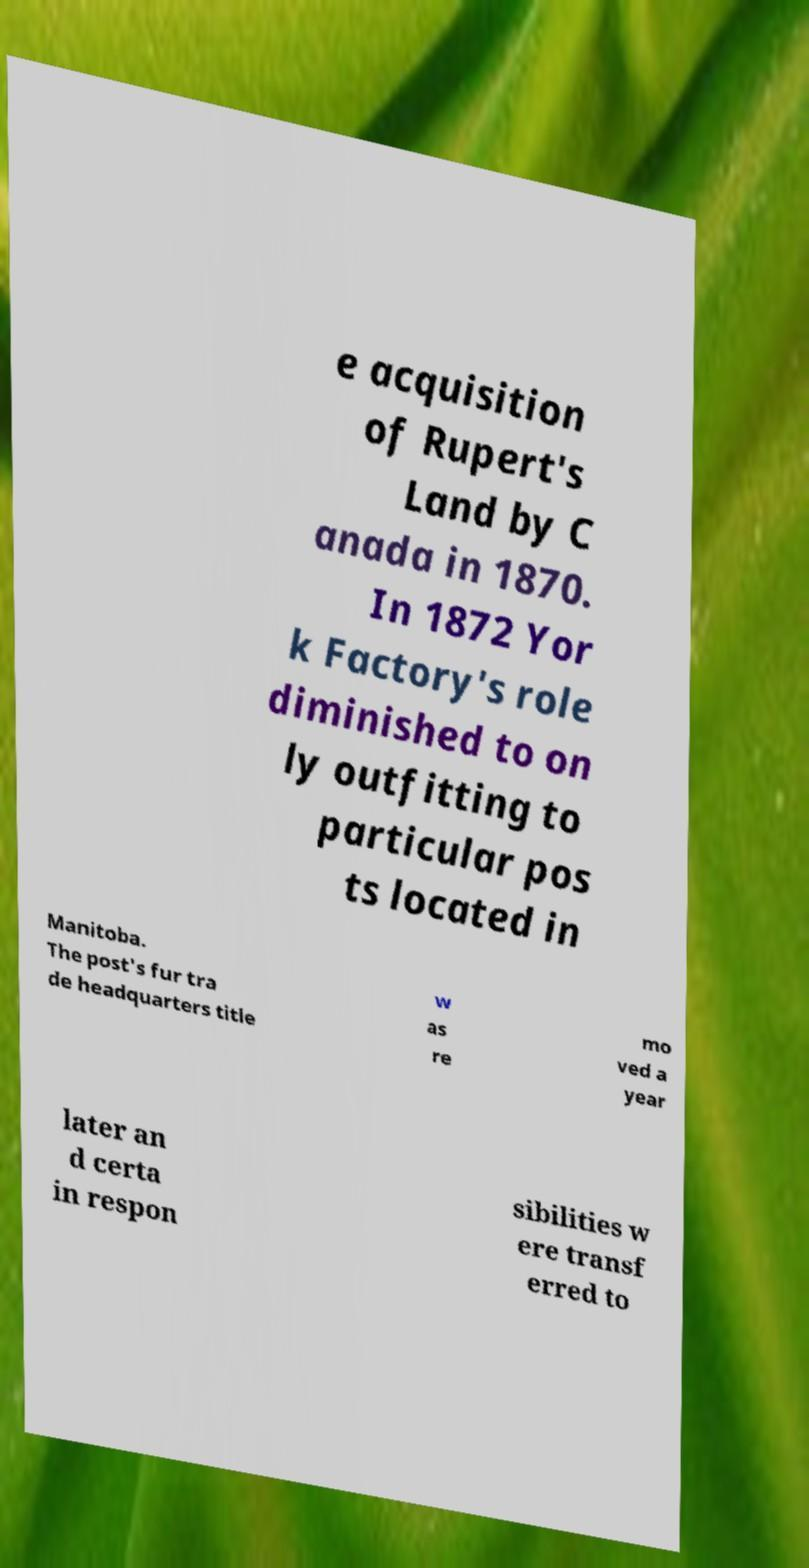Could you extract and type out the text from this image? e acquisition of Rupert's Land by C anada in 1870. In 1872 Yor k Factory's role diminished to on ly outfitting to particular pos ts located in Manitoba. The post's fur tra de headquarters title w as re mo ved a year later an d certa in respon sibilities w ere transf erred to 